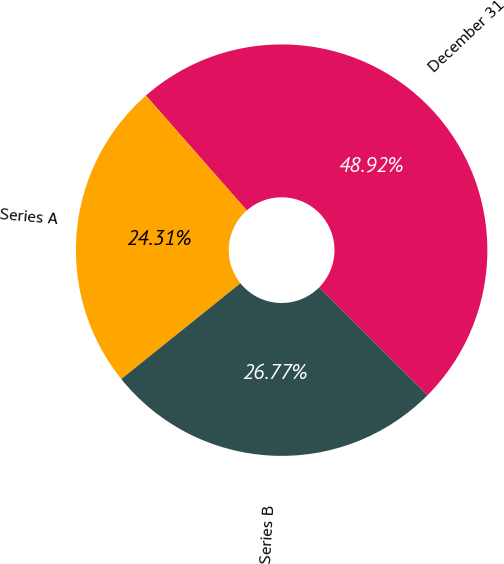Convert chart. <chart><loc_0><loc_0><loc_500><loc_500><pie_chart><fcel>December 31<fcel>Series A<fcel>Series B<nl><fcel>48.92%<fcel>24.31%<fcel>26.77%<nl></chart> 